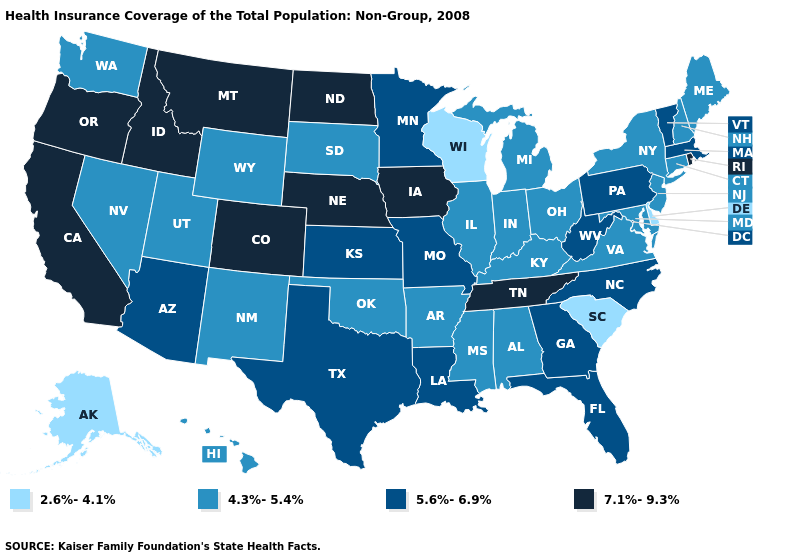Name the states that have a value in the range 2.6%-4.1%?
Quick response, please. Alaska, Delaware, South Carolina, Wisconsin. Name the states that have a value in the range 4.3%-5.4%?
Write a very short answer. Alabama, Arkansas, Connecticut, Hawaii, Illinois, Indiana, Kentucky, Maine, Maryland, Michigan, Mississippi, Nevada, New Hampshire, New Jersey, New Mexico, New York, Ohio, Oklahoma, South Dakota, Utah, Virginia, Washington, Wyoming. Name the states that have a value in the range 5.6%-6.9%?
Concise answer only. Arizona, Florida, Georgia, Kansas, Louisiana, Massachusetts, Minnesota, Missouri, North Carolina, Pennsylvania, Texas, Vermont, West Virginia. What is the highest value in the West ?
Give a very brief answer. 7.1%-9.3%. What is the highest value in states that border New Hampshire?
Write a very short answer. 5.6%-6.9%. Name the states that have a value in the range 7.1%-9.3%?
Give a very brief answer. California, Colorado, Idaho, Iowa, Montana, Nebraska, North Dakota, Oregon, Rhode Island, Tennessee. What is the highest value in the USA?
Quick response, please. 7.1%-9.3%. Which states hav the highest value in the South?
Short answer required. Tennessee. Does Michigan have the same value as Oklahoma?
Quick response, please. Yes. Does Wisconsin have the lowest value in the USA?
Concise answer only. Yes. What is the lowest value in the USA?
Answer briefly. 2.6%-4.1%. Does Wisconsin have the lowest value in the MidWest?
Short answer required. Yes. What is the value of Georgia?
Answer briefly. 5.6%-6.9%. Which states hav the highest value in the South?
Answer briefly. Tennessee. What is the highest value in the MidWest ?
Short answer required. 7.1%-9.3%. 